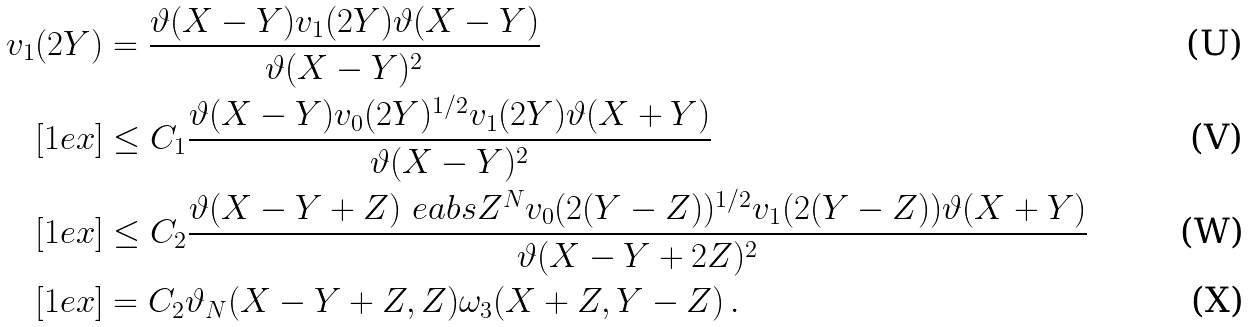<formula> <loc_0><loc_0><loc_500><loc_500>v _ { 1 } ( 2 Y ) & = \frac { \vartheta ( X - Y ) v _ { 1 } ( 2 Y ) \vartheta ( X - Y ) } { \vartheta ( X - Y ) ^ { 2 } } \\ [ 1 e x ] & \leq C _ { 1 } \frac { \vartheta ( X - Y ) v _ { 0 } ( 2 Y ) ^ { 1 / 2 } v _ { 1 } ( 2 Y ) \vartheta ( X + Y ) } { \vartheta ( X - Y ) ^ { 2 } } \\ [ 1 e x ] & \leq C _ { 2 } \frac { \vartheta ( X - Y + Z ) \ e a b s Z ^ { N } v _ { 0 } ( 2 ( Y - Z ) ) ^ { 1 / 2 } v _ { 1 } ( 2 ( Y - Z ) ) \vartheta ( X + Y ) } { \vartheta ( X - Y + 2 Z ) ^ { 2 } } \\ [ 1 e x ] & = C _ { 2 } \vartheta _ { N } ( X - Y + Z , Z ) \omega _ { 3 } ( X + Z , Y - Z ) \, .</formula> 